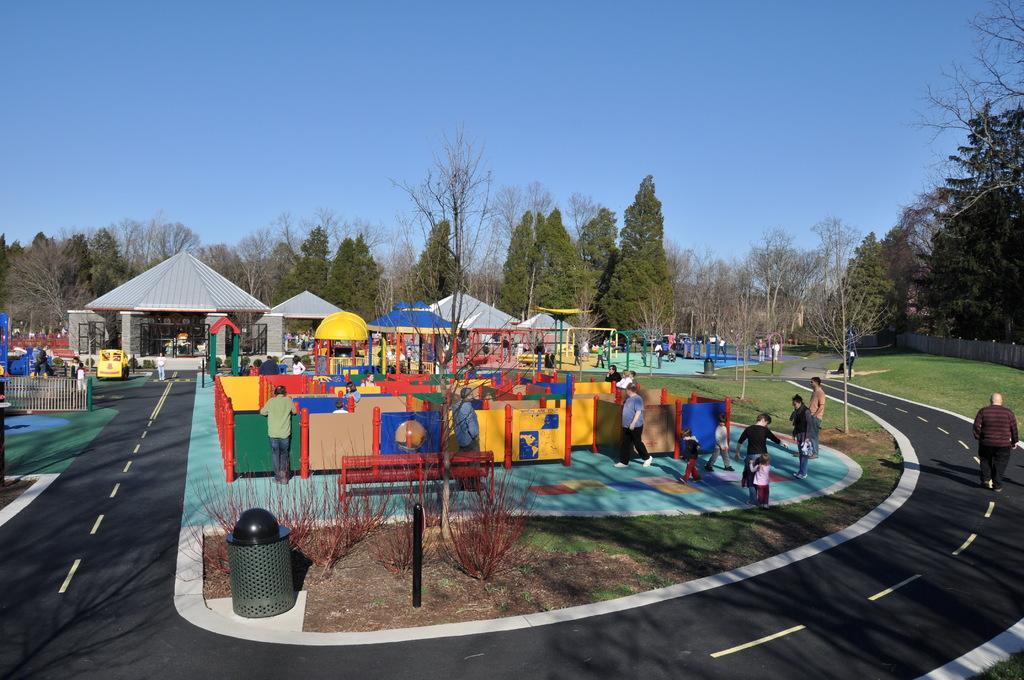Could you give a brief overview of what you see in this image? This image is taken outdoors. At the top of the image there is the sky. In the background there are many trees on the ground. There is a house and there are a few stores. Many people are standing on the ground and a few are walking. There is a playstation in the middle of the image. On the left side of the image there is a fence. There is a road. In the middle of the image there is a tree. There is an empty bench and there is a dustbin on the ground. On the right side of the image there is a wooden fence. There is a ground with grass on it and a man is walking on the road. 